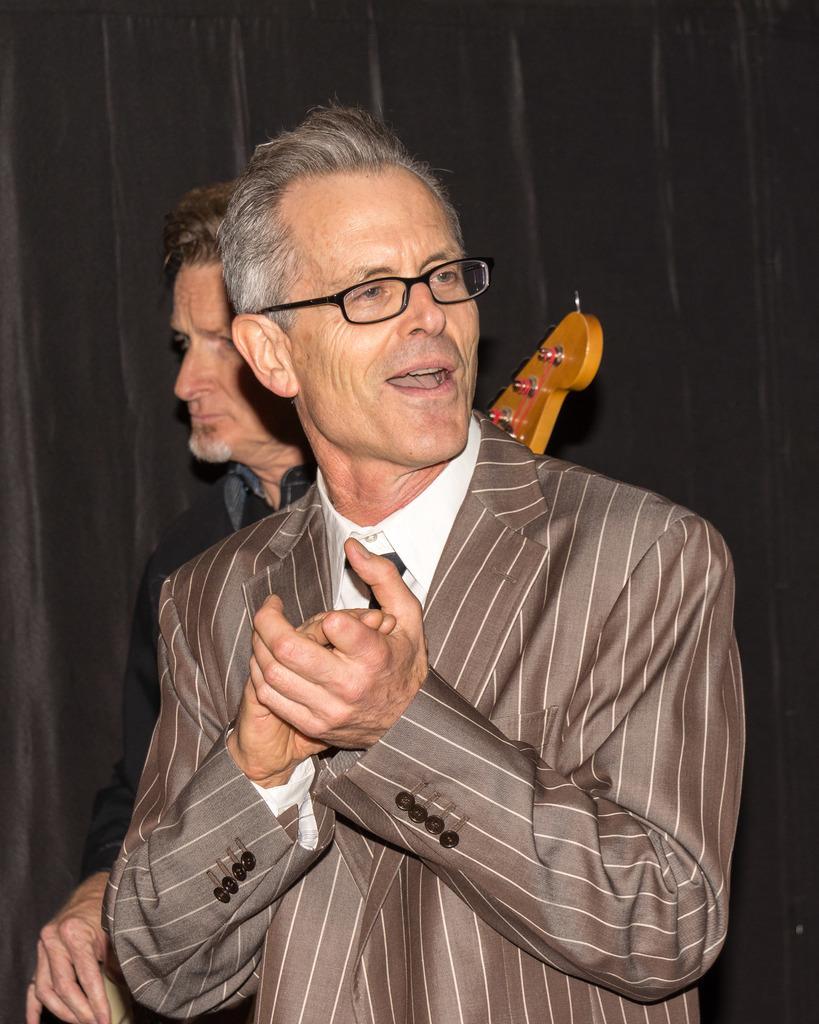Please provide a concise description of this image. In this image I can see a person wearing white colored shirt, black colored tie and blazer is standing. In the background I can see a person holding a musical instrument and the black colored curtain. 